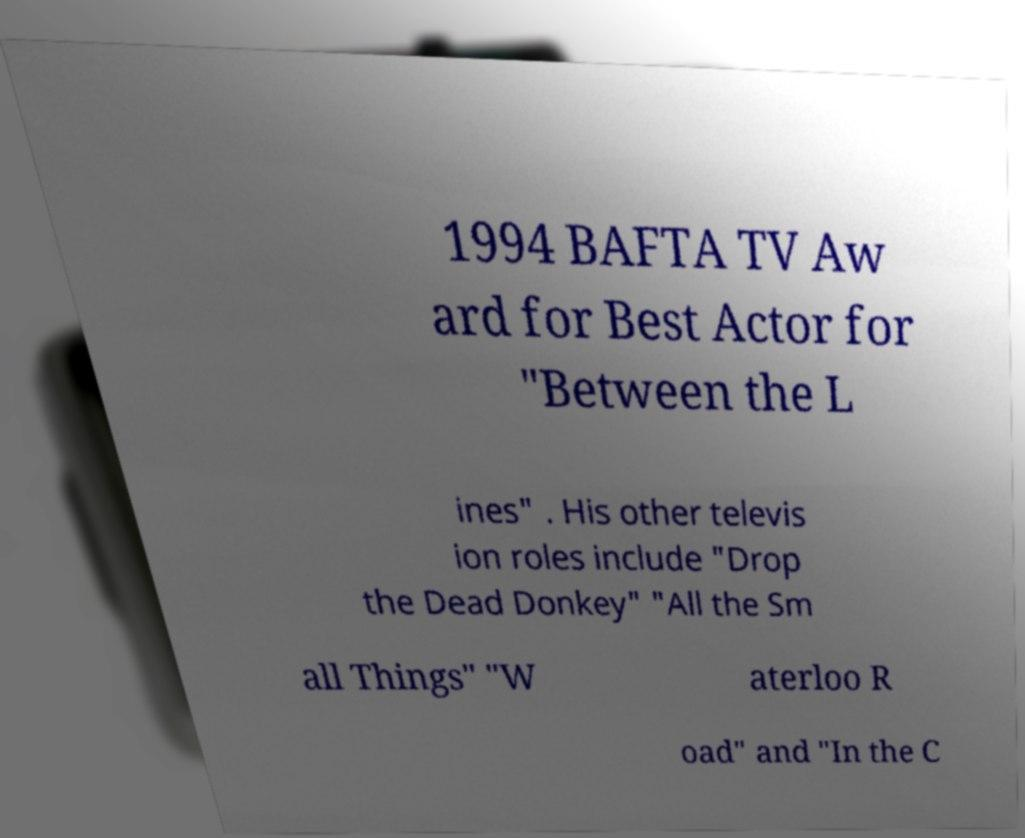Please read and relay the text visible in this image. What does it say? 1994 BAFTA TV Aw ard for Best Actor for "Between the L ines" . His other televis ion roles include "Drop the Dead Donkey" "All the Sm all Things" "W aterloo R oad" and "In the C 